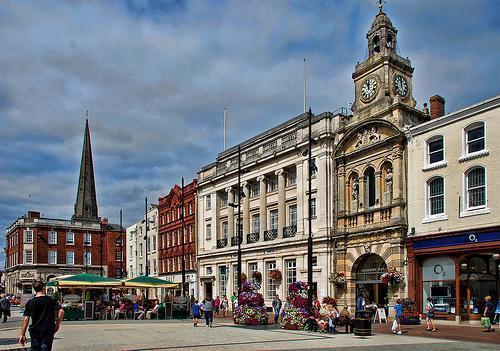How many umbrellas are there?
Give a very brief answer. 2. 